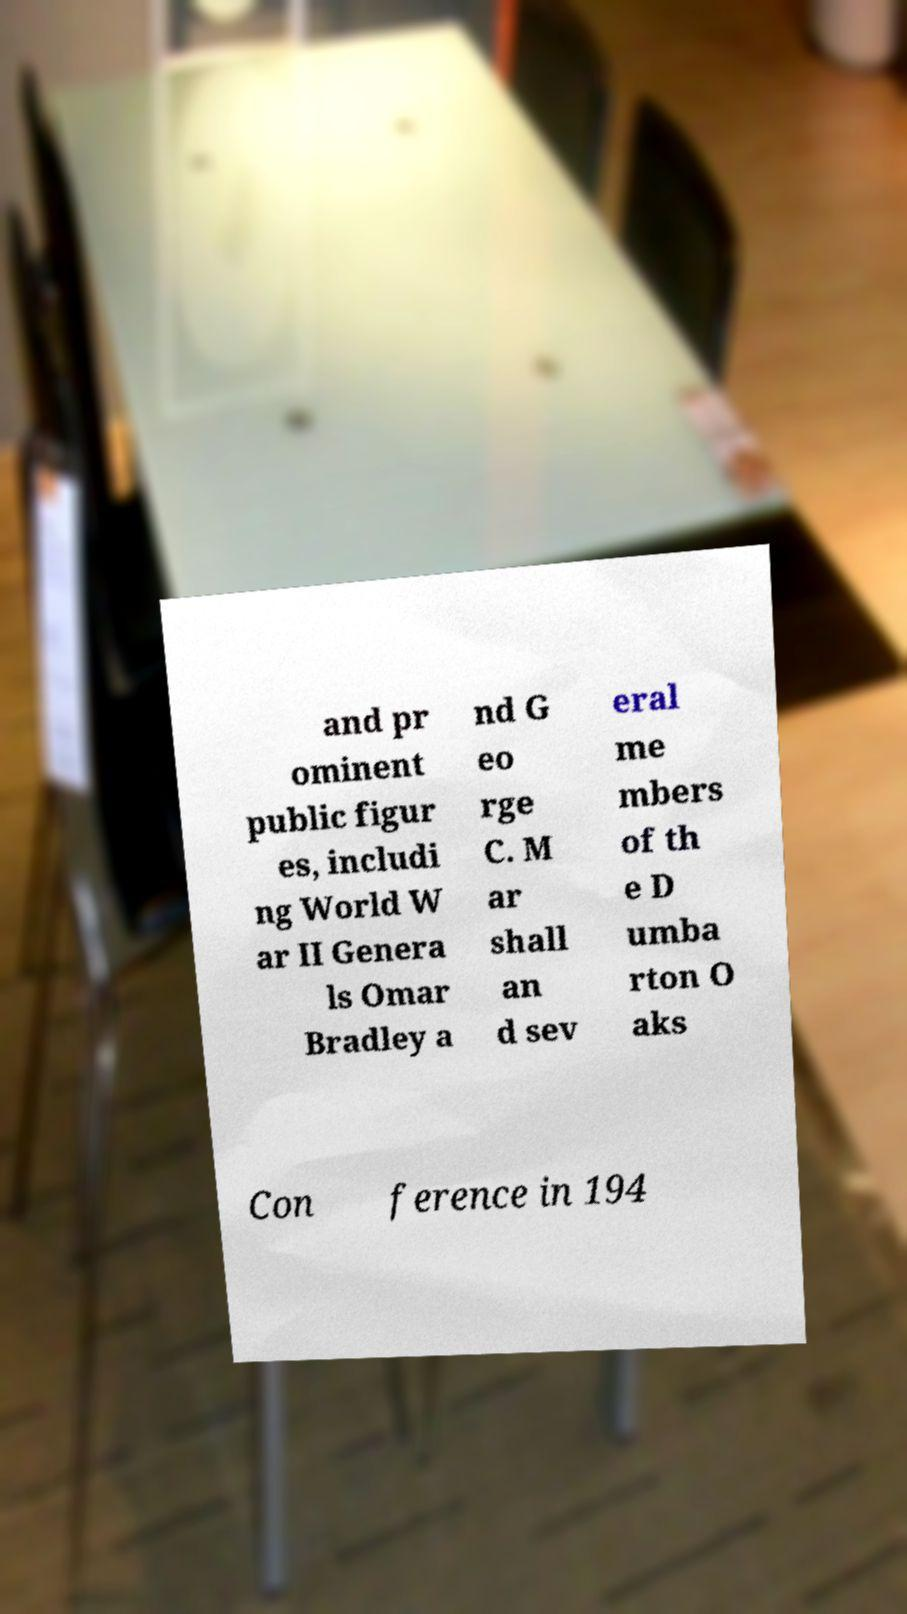Please identify and transcribe the text found in this image. and pr ominent public figur es, includi ng World W ar II Genera ls Omar Bradley a nd G eo rge C. M ar shall an d sev eral me mbers of th e D umba rton O aks Con ference in 194 